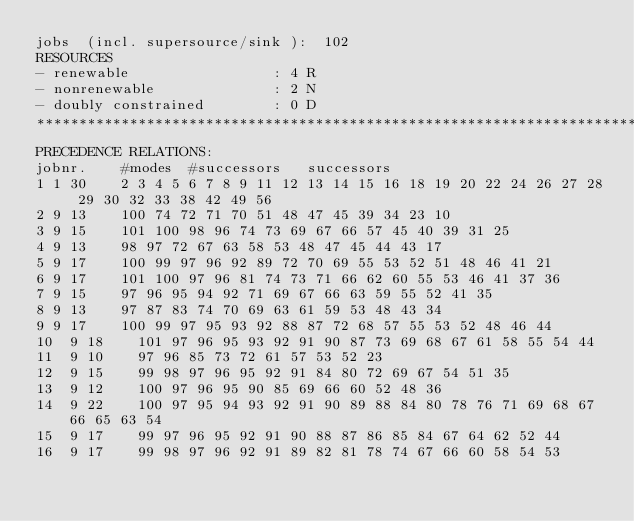<code> <loc_0><loc_0><loc_500><loc_500><_ObjectiveC_>jobs  (incl. supersource/sink ):	102
RESOURCES
- renewable                 : 4 R
- nonrenewable              : 2 N
- doubly constrained        : 0 D
************************************************************************
PRECEDENCE RELATIONS:
jobnr.    #modes  #successors   successors
1	1	30		2 3 4 5 6 7 8 9 11 12 13 14 15 16 18 19 20 22 24 26 27 28 29 30 32 33 38 42 49 56 
2	9	13		100 74 72 71 70 51 48 47 45 39 34 23 10 
3	9	15		101 100 98 96 74 73 69 67 66 57 45 40 39 31 25 
4	9	13		98 97 72 67 63 58 53 48 47 45 44 43 17 
5	9	17		100 99 97 96 92 89 72 70 69 55 53 52 51 48 46 41 21 
6	9	17		101 100 97 96 81 74 73 71 66 62 60 55 53 46 41 37 36 
7	9	15		97 96 95 94 92 71 69 67 66 63 59 55 52 41 35 
8	9	13		97 87 83 74 70 69 63 61 59 53 48 43 34 
9	9	17		100 99 97 95 93 92 88 87 72 68 57 55 53 52 48 46 44 
10	9	18		101 97 96 95 93 92 91 90 87 73 69 68 67 61 58 55 54 44 
11	9	10		97 96 85 73 72 61 57 53 52 23 
12	9	15		99 98 97 96 95 92 91 84 80 72 69 67 54 51 35 
13	9	12		100 97 96 95 90 85 69 66 60 52 48 36 
14	9	22		100 97 95 94 93 92 91 90 89 88 84 80 78 76 71 69 68 67 66 65 63 54 
15	9	17		99 97 96 95 92 91 90 88 87 86 85 84 67 64 62 52 44 
16	9	17		99 98 97 96 92 91 89 82 81 78 74 67 66 60 58 54 53 </code> 